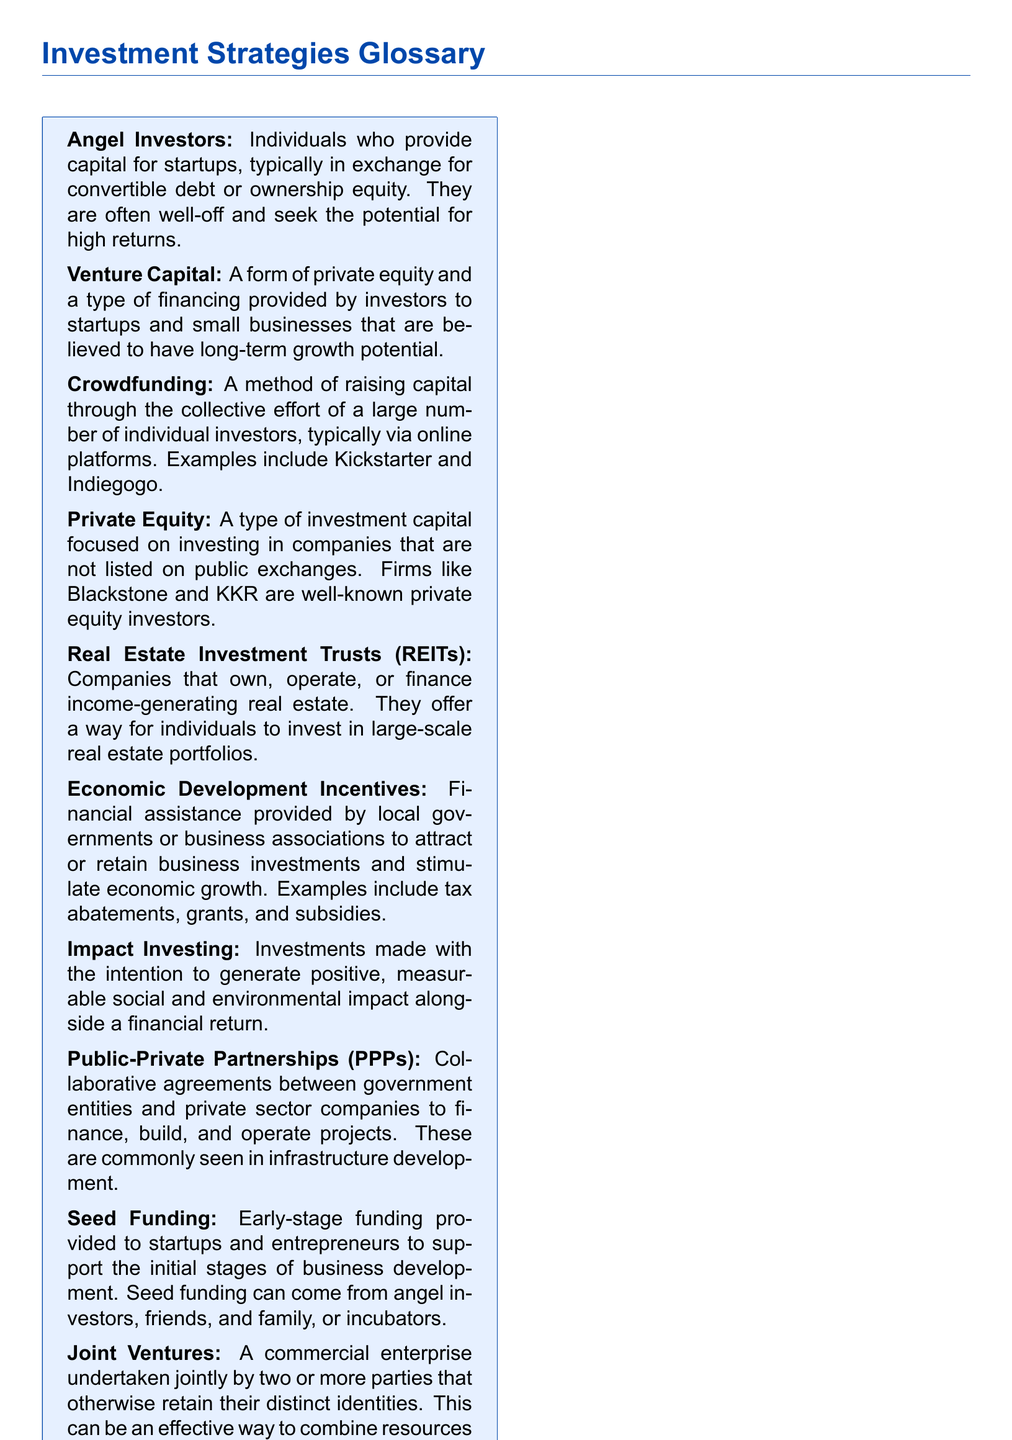What are angel investors? Angel investors are individuals who provide capital for startups, typically in exchange for convertible debt or ownership equity.
Answer: Individuals providing capital What is crowdfunding? Crowdfunding is a method of raising capital through the collective effort of a large number of individual investors, typically via online platforms.
Answer: Collective effort of individual investors What do Private Equity firms focus on? Private Equity firms focus on investing in companies that are not listed on public exchanges.
Answer: Non-listed companies What is seed funding? Seed funding is early-stage funding provided to startups and entrepreneurs to support the initial stages of business development.
Answer: Early-stage funding What is the purpose of Economic Development Incentives? Economic Development Incentives aim to attract or retain business investments and stimulate economic growth.
Answer: Attract business investments What is the difference between angel investors and venture capital? Angel investors typically invest their own funds, while venture capital involves a group of investors providing capital.
Answer: Individual vs. group investment What type of investment generates social and environmental impact? Impact Investing is made with the intention to generate positive, measurable social and environmental impact alongside a financial return.
Answer: Impact Investing What do Real Estate Investment Trusts (REITs) focus on? REITs focus on owning, operating, or financing income-generating real estate.
Answer: Income-generating real estate What is a Joint Venture? A Joint Venture is a commercial enterprise undertaken jointly by two or more parties that otherwise retain their distinct identities.
Answer: Jointly undertaken enterprise 